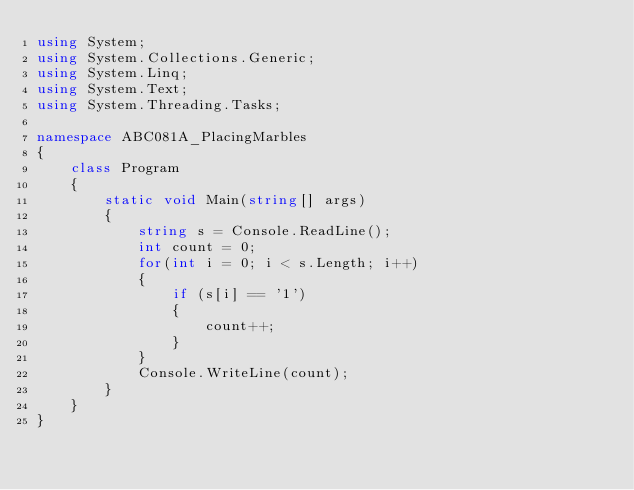Convert code to text. <code><loc_0><loc_0><loc_500><loc_500><_C#_>using System;
using System.Collections.Generic;
using System.Linq;
using System.Text;
using System.Threading.Tasks;

namespace ABC081A_PlacingMarbles
{
    class Program
    {
        static void Main(string[] args)
        {
            string s = Console.ReadLine();
            int count = 0;
            for(int i = 0; i < s.Length; i++)
            {
                if (s[i] == '1')
                {
                    count++;
                }
            }
            Console.WriteLine(count);
        }
    }
}
</code> 